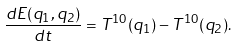<formula> <loc_0><loc_0><loc_500><loc_500>\frac { d E ( q _ { 1 } , q _ { 2 } ) } { d t } = T ^ { 1 0 } ( q _ { 1 } ) - T ^ { 1 0 } ( q _ { 2 } ) .</formula> 